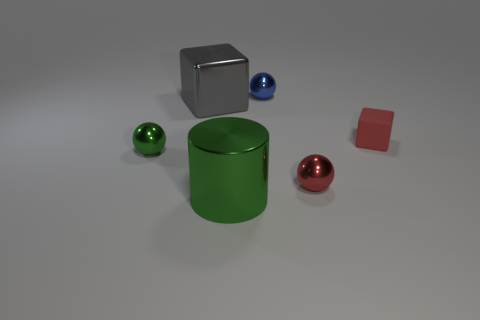How many blue cylinders are there?
Your answer should be compact. 0. What number of things are both behind the small green metallic ball and on the right side of the big gray cube?
Offer a very short reply. 2. Is there any other thing that is the same shape as the large green shiny thing?
Give a very brief answer. No. Is the color of the small block the same as the small metallic object that is on the right side of the tiny blue thing?
Ensure brevity in your answer.  Yes. There is a large thing that is behind the red shiny object; what shape is it?
Offer a very short reply. Cube. How many other things are the same material as the small block?
Your response must be concise. 0. What is the big gray thing made of?
Your answer should be compact. Metal. What number of big things are either blue shiny balls or objects?
Ensure brevity in your answer.  2. There is a big green metal cylinder; how many large blocks are in front of it?
Provide a short and direct response. 0. Is there a tiny sphere of the same color as the tiny rubber cube?
Provide a short and direct response. Yes. 